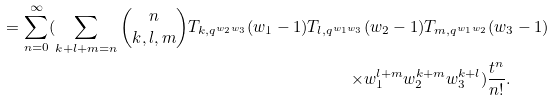Convert formula to latex. <formula><loc_0><loc_0><loc_500><loc_500>= \sum _ { n = 0 } ^ { \infty } ( \sum _ { k + l + m = n } \binom { n } { k , l , m } T _ { k , q ^ { w _ { 2 } w _ { 3 } } } ( w _ { 1 } - 1 ) T _ { l , q ^ { w _ { 1 } w _ { 3 } } } & ( w _ { 2 } - 1 ) T _ { m , q ^ { w _ { 1 } w _ { 2 } } } ( w _ { 3 } - 1 ) \\ \times & w _ { 1 } ^ { l + m } w _ { 2 } ^ { k + m } w _ { 3 } ^ { k + l } ) \frac { t ^ { n } } { n ! } .</formula> 